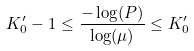<formula> <loc_0><loc_0><loc_500><loc_500>K _ { 0 } ^ { \prime } - 1 \leq \frac { - \log ( P ) } { \log ( \mu ) } \leq K _ { 0 } ^ { \prime }</formula> 